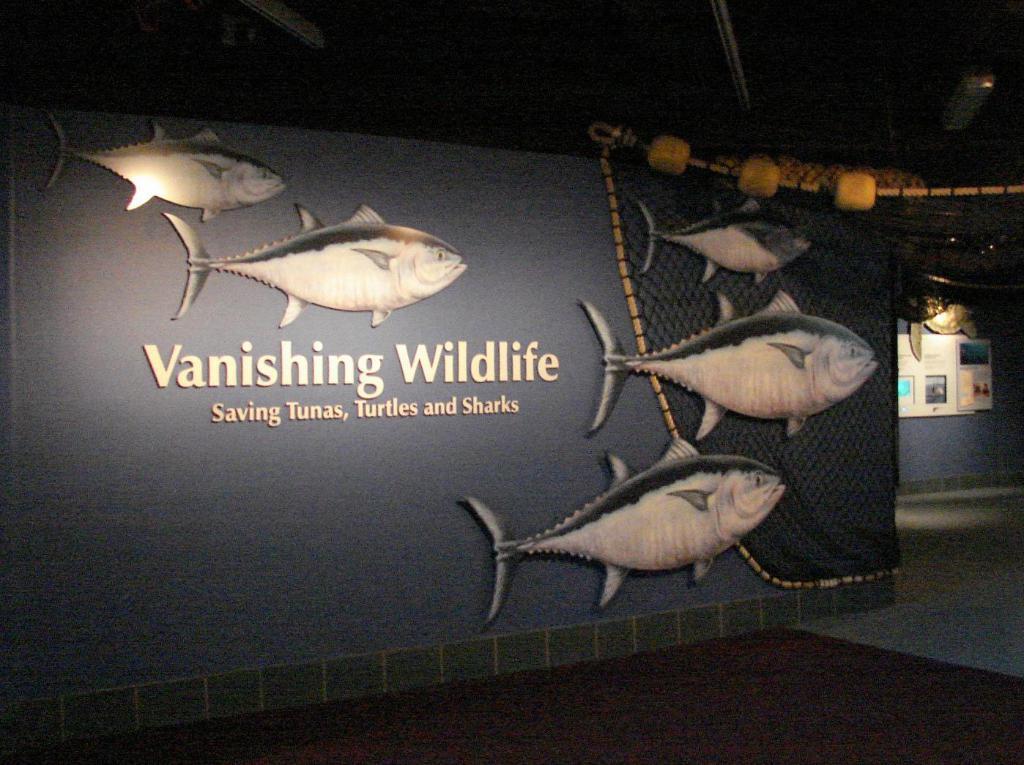How would you summarize this image in a sentence or two? In this image there are pictures of fishes on the wall and there is a text on the wall. At the back there are boards on the wall and there is a text on the boards. At the top there is a light. 